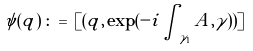<formula> <loc_0><loc_0><loc_500><loc_500>\psi ( q ) \, \colon = \, [ ( q , \exp ( - i \int _ { \gamma _ { 1 } } A , \gamma ) ) ]</formula> 